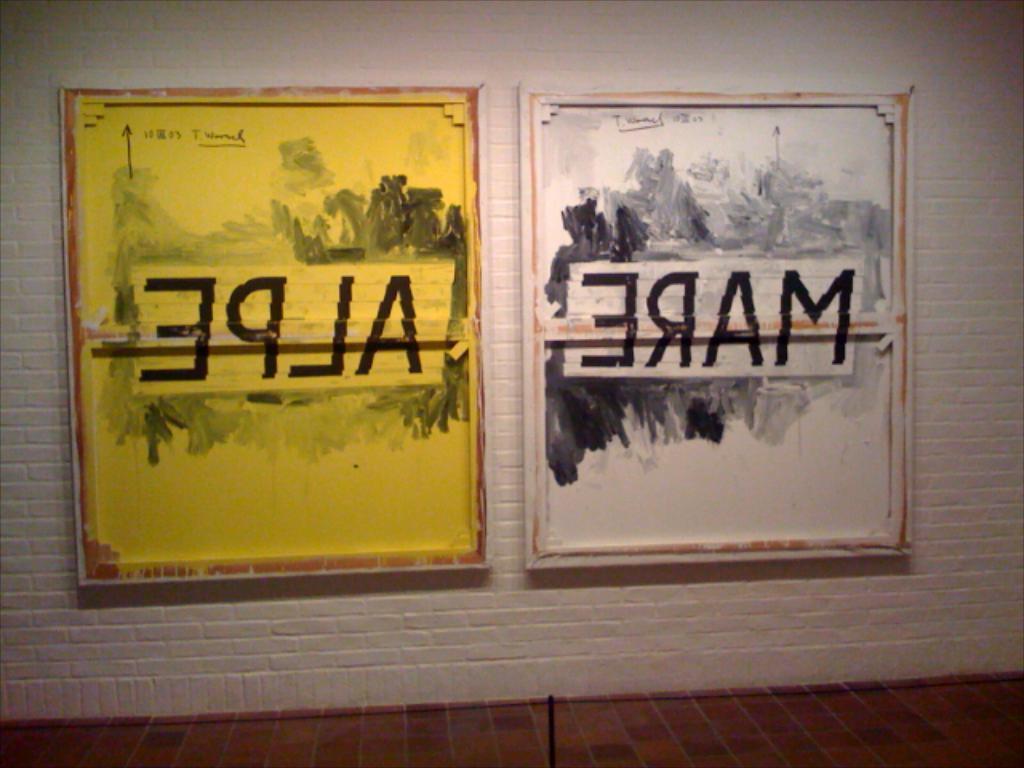What is written across the two frames?
Your answer should be compact. Mare alpe. This is photo frame?
Your answer should be very brief. Answering does not require reading text in the image. 